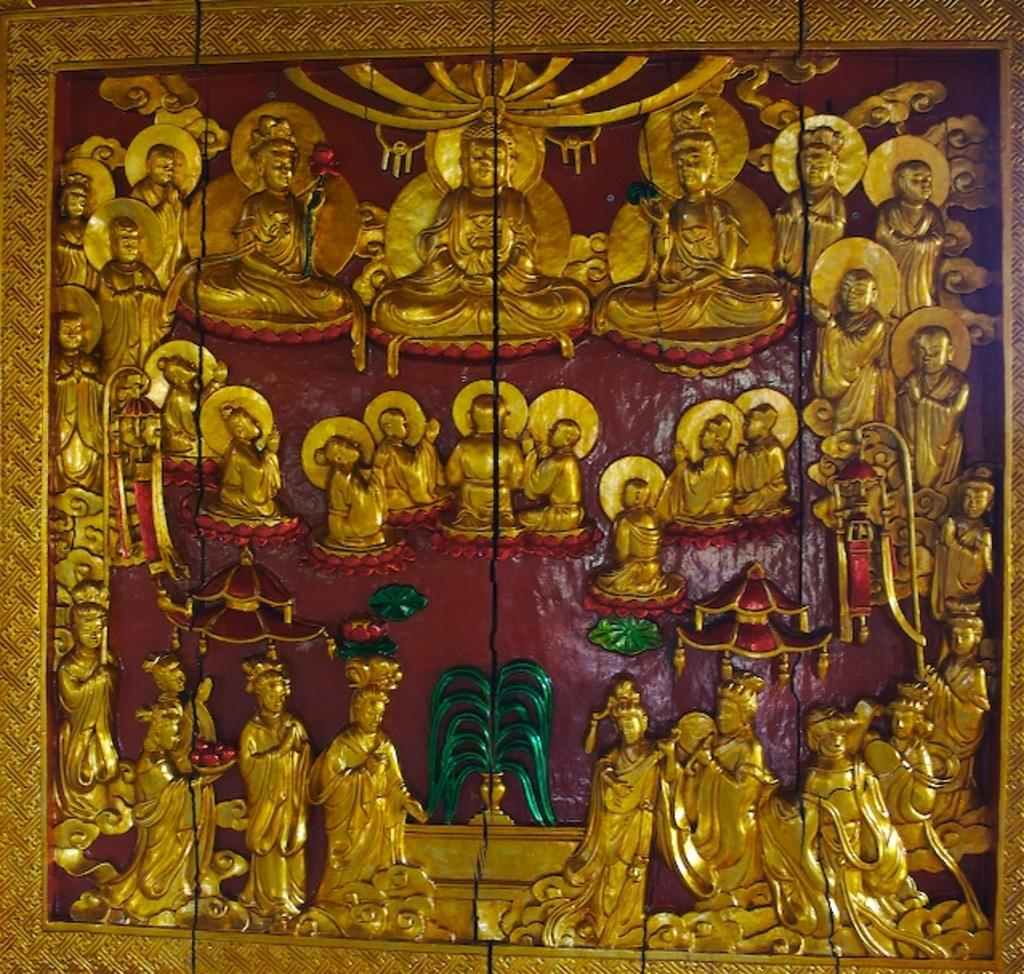What is depicted on the wall in the image? There are sculptures on the wall in the image. What color is the background of the image? The background of the image is red in color. Where is the drain located in the image? There is no drain present in the image. How many bears can be seen in the image? There are no bears present in the image. 